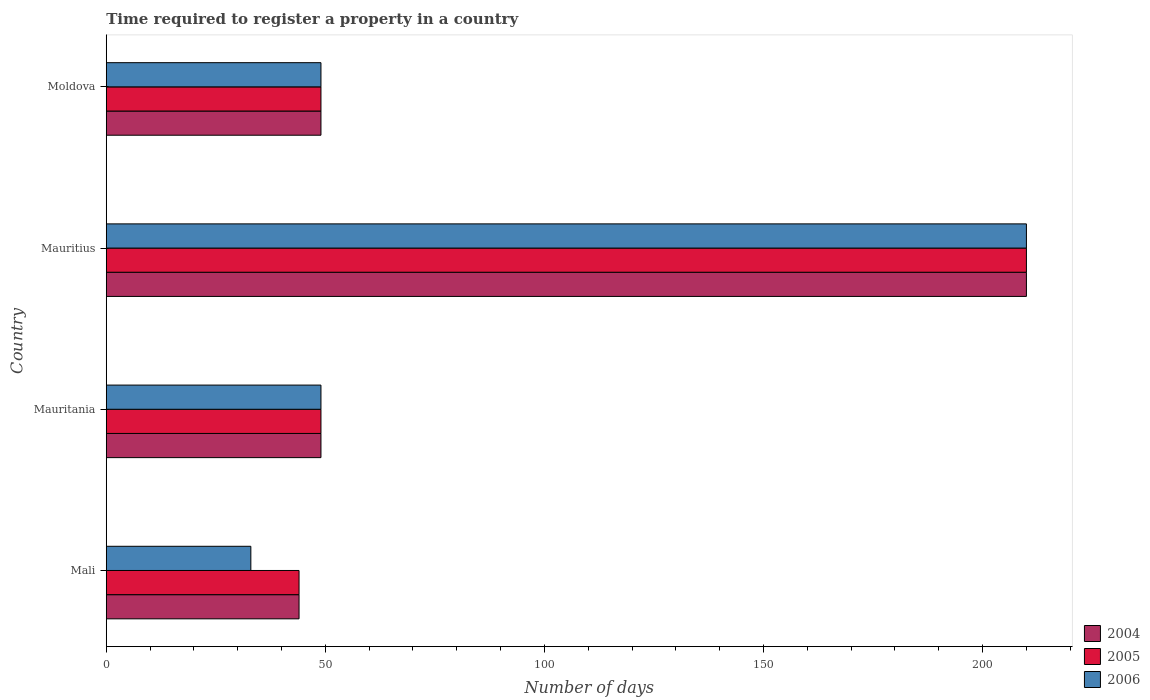How many different coloured bars are there?
Provide a short and direct response. 3. Are the number of bars per tick equal to the number of legend labels?
Offer a terse response. Yes. Are the number of bars on each tick of the Y-axis equal?
Make the answer very short. Yes. How many bars are there on the 2nd tick from the top?
Make the answer very short. 3. How many bars are there on the 1st tick from the bottom?
Keep it short and to the point. 3. What is the label of the 3rd group of bars from the top?
Make the answer very short. Mauritania. Across all countries, what is the maximum number of days required to register a property in 2005?
Your answer should be compact. 210. Across all countries, what is the minimum number of days required to register a property in 2004?
Provide a short and direct response. 44. In which country was the number of days required to register a property in 2004 maximum?
Your answer should be very brief. Mauritius. In which country was the number of days required to register a property in 2006 minimum?
Your answer should be very brief. Mali. What is the total number of days required to register a property in 2004 in the graph?
Ensure brevity in your answer.  352. What is the difference between the number of days required to register a property in 2005 in Mauritius and that in Moldova?
Your response must be concise. 161. What is the difference between the number of days required to register a property in 2005 in Moldova and the number of days required to register a property in 2006 in Mali?
Make the answer very short. 16. In how many countries, is the number of days required to register a property in 2004 greater than 190 days?
Your answer should be very brief. 1. What is the ratio of the number of days required to register a property in 2004 in Mauritania to that in Mauritius?
Your response must be concise. 0.23. What is the difference between the highest and the second highest number of days required to register a property in 2005?
Your answer should be very brief. 161. What is the difference between the highest and the lowest number of days required to register a property in 2004?
Offer a terse response. 166. In how many countries, is the number of days required to register a property in 2004 greater than the average number of days required to register a property in 2004 taken over all countries?
Offer a very short reply. 1. Is the sum of the number of days required to register a property in 2005 in Mali and Mauritius greater than the maximum number of days required to register a property in 2004 across all countries?
Provide a short and direct response. Yes. What does the 2nd bar from the top in Mauritania represents?
Keep it short and to the point. 2005. What does the 2nd bar from the bottom in Mauritius represents?
Give a very brief answer. 2005. How many bars are there?
Keep it short and to the point. 12. Are all the bars in the graph horizontal?
Keep it short and to the point. Yes. What is the difference between two consecutive major ticks on the X-axis?
Your response must be concise. 50. Does the graph contain any zero values?
Make the answer very short. No. Does the graph contain grids?
Provide a short and direct response. No. Where does the legend appear in the graph?
Keep it short and to the point. Bottom right. How many legend labels are there?
Provide a short and direct response. 3. How are the legend labels stacked?
Your answer should be very brief. Vertical. What is the title of the graph?
Your answer should be compact. Time required to register a property in a country. What is the label or title of the X-axis?
Give a very brief answer. Number of days. What is the label or title of the Y-axis?
Keep it short and to the point. Country. What is the Number of days in 2004 in Mali?
Your answer should be very brief. 44. What is the Number of days of 2006 in Mali?
Your answer should be very brief. 33. What is the Number of days in 2004 in Mauritania?
Ensure brevity in your answer.  49. What is the Number of days of 2005 in Mauritania?
Keep it short and to the point. 49. What is the Number of days of 2004 in Mauritius?
Give a very brief answer. 210. What is the Number of days in 2005 in Mauritius?
Ensure brevity in your answer.  210. What is the Number of days of 2006 in Mauritius?
Your response must be concise. 210. What is the Number of days of 2004 in Moldova?
Your response must be concise. 49. What is the Number of days of 2005 in Moldova?
Offer a terse response. 49. Across all countries, what is the maximum Number of days in 2004?
Give a very brief answer. 210. Across all countries, what is the maximum Number of days of 2005?
Provide a succinct answer. 210. Across all countries, what is the maximum Number of days of 2006?
Keep it short and to the point. 210. Across all countries, what is the minimum Number of days in 2004?
Make the answer very short. 44. Across all countries, what is the minimum Number of days in 2005?
Provide a short and direct response. 44. Across all countries, what is the minimum Number of days of 2006?
Make the answer very short. 33. What is the total Number of days in 2004 in the graph?
Keep it short and to the point. 352. What is the total Number of days in 2005 in the graph?
Ensure brevity in your answer.  352. What is the total Number of days in 2006 in the graph?
Make the answer very short. 341. What is the difference between the Number of days in 2004 in Mali and that in Mauritania?
Give a very brief answer. -5. What is the difference between the Number of days in 2006 in Mali and that in Mauritania?
Provide a short and direct response. -16. What is the difference between the Number of days of 2004 in Mali and that in Mauritius?
Give a very brief answer. -166. What is the difference between the Number of days in 2005 in Mali and that in Mauritius?
Your answer should be very brief. -166. What is the difference between the Number of days in 2006 in Mali and that in Mauritius?
Ensure brevity in your answer.  -177. What is the difference between the Number of days in 2004 in Mali and that in Moldova?
Provide a short and direct response. -5. What is the difference between the Number of days of 2004 in Mauritania and that in Mauritius?
Offer a very short reply. -161. What is the difference between the Number of days of 2005 in Mauritania and that in Mauritius?
Your answer should be compact. -161. What is the difference between the Number of days of 2006 in Mauritania and that in Mauritius?
Offer a terse response. -161. What is the difference between the Number of days of 2004 in Mauritania and that in Moldova?
Give a very brief answer. 0. What is the difference between the Number of days in 2005 in Mauritania and that in Moldova?
Your answer should be compact. 0. What is the difference between the Number of days of 2006 in Mauritania and that in Moldova?
Keep it short and to the point. 0. What is the difference between the Number of days of 2004 in Mauritius and that in Moldova?
Ensure brevity in your answer.  161. What is the difference between the Number of days in 2005 in Mauritius and that in Moldova?
Give a very brief answer. 161. What is the difference between the Number of days of 2006 in Mauritius and that in Moldova?
Your answer should be compact. 161. What is the difference between the Number of days in 2004 in Mali and the Number of days in 2005 in Mauritania?
Make the answer very short. -5. What is the difference between the Number of days of 2004 in Mali and the Number of days of 2006 in Mauritania?
Your response must be concise. -5. What is the difference between the Number of days in 2004 in Mali and the Number of days in 2005 in Mauritius?
Offer a very short reply. -166. What is the difference between the Number of days of 2004 in Mali and the Number of days of 2006 in Mauritius?
Offer a terse response. -166. What is the difference between the Number of days in 2005 in Mali and the Number of days in 2006 in Mauritius?
Your response must be concise. -166. What is the difference between the Number of days of 2005 in Mali and the Number of days of 2006 in Moldova?
Offer a terse response. -5. What is the difference between the Number of days of 2004 in Mauritania and the Number of days of 2005 in Mauritius?
Offer a very short reply. -161. What is the difference between the Number of days in 2004 in Mauritania and the Number of days in 2006 in Mauritius?
Offer a very short reply. -161. What is the difference between the Number of days in 2005 in Mauritania and the Number of days in 2006 in Mauritius?
Your answer should be very brief. -161. What is the difference between the Number of days of 2004 in Mauritania and the Number of days of 2005 in Moldova?
Ensure brevity in your answer.  0. What is the difference between the Number of days in 2005 in Mauritania and the Number of days in 2006 in Moldova?
Your answer should be compact. 0. What is the difference between the Number of days in 2004 in Mauritius and the Number of days in 2005 in Moldova?
Your answer should be compact. 161. What is the difference between the Number of days of 2004 in Mauritius and the Number of days of 2006 in Moldova?
Your answer should be compact. 161. What is the difference between the Number of days of 2005 in Mauritius and the Number of days of 2006 in Moldova?
Your response must be concise. 161. What is the average Number of days in 2004 per country?
Your answer should be very brief. 88. What is the average Number of days in 2006 per country?
Offer a terse response. 85.25. What is the difference between the Number of days in 2004 and Number of days in 2006 in Mali?
Offer a very short reply. 11. What is the difference between the Number of days in 2005 and Number of days in 2006 in Mali?
Offer a very short reply. 11. What is the difference between the Number of days in 2004 and Number of days in 2006 in Mauritania?
Make the answer very short. 0. What is the difference between the Number of days in 2005 and Number of days in 2006 in Mauritania?
Your answer should be compact. 0. What is the difference between the Number of days in 2004 and Number of days in 2006 in Mauritius?
Keep it short and to the point. 0. What is the difference between the Number of days in 2005 and Number of days in 2006 in Mauritius?
Give a very brief answer. 0. What is the difference between the Number of days of 2005 and Number of days of 2006 in Moldova?
Give a very brief answer. 0. What is the ratio of the Number of days in 2004 in Mali to that in Mauritania?
Your response must be concise. 0.9. What is the ratio of the Number of days of 2005 in Mali to that in Mauritania?
Provide a short and direct response. 0.9. What is the ratio of the Number of days of 2006 in Mali to that in Mauritania?
Give a very brief answer. 0.67. What is the ratio of the Number of days of 2004 in Mali to that in Mauritius?
Offer a very short reply. 0.21. What is the ratio of the Number of days of 2005 in Mali to that in Mauritius?
Provide a succinct answer. 0.21. What is the ratio of the Number of days in 2006 in Mali to that in Mauritius?
Offer a terse response. 0.16. What is the ratio of the Number of days in 2004 in Mali to that in Moldova?
Your answer should be very brief. 0.9. What is the ratio of the Number of days of 2005 in Mali to that in Moldova?
Provide a short and direct response. 0.9. What is the ratio of the Number of days in 2006 in Mali to that in Moldova?
Provide a succinct answer. 0.67. What is the ratio of the Number of days in 2004 in Mauritania to that in Mauritius?
Provide a succinct answer. 0.23. What is the ratio of the Number of days in 2005 in Mauritania to that in Mauritius?
Provide a succinct answer. 0.23. What is the ratio of the Number of days in 2006 in Mauritania to that in Mauritius?
Provide a succinct answer. 0.23. What is the ratio of the Number of days in 2004 in Mauritius to that in Moldova?
Offer a terse response. 4.29. What is the ratio of the Number of days in 2005 in Mauritius to that in Moldova?
Provide a short and direct response. 4.29. What is the ratio of the Number of days of 2006 in Mauritius to that in Moldova?
Give a very brief answer. 4.29. What is the difference between the highest and the second highest Number of days of 2004?
Keep it short and to the point. 161. What is the difference between the highest and the second highest Number of days of 2005?
Your answer should be very brief. 161. What is the difference between the highest and the second highest Number of days of 2006?
Give a very brief answer. 161. What is the difference between the highest and the lowest Number of days of 2004?
Your answer should be compact. 166. What is the difference between the highest and the lowest Number of days of 2005?
Provide a short and direct response. 166. What is the difference between the highest and the lowest Number of days in 2006?
Offer a very short reply. 177. 